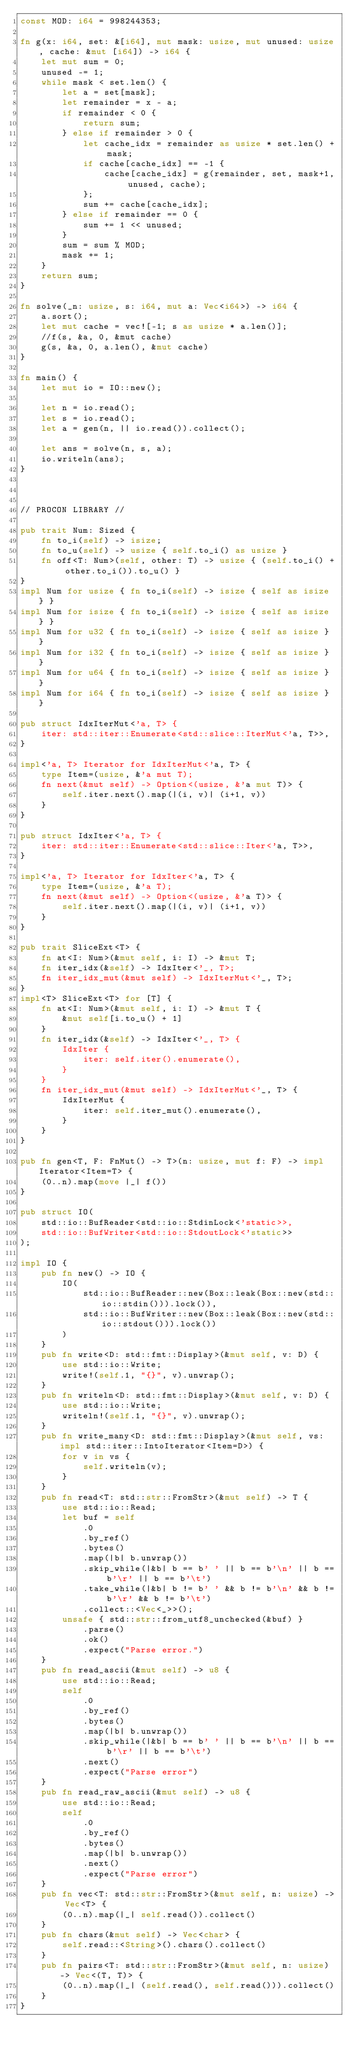<code> <loc_0><loc_0><loc_500><loc_500><_Rust_>const MOD: i64 = 998244353;

fn g(x: i64, set: &[i64], mut mask: usize, mut unused: usize, cache: &mut [i64]) -> i64 {
    let mut sum = 0;
    unused -= 1;
    while mask < set.len() {
        let a = set[mask];
        let remainder = x - a;
        if remainder < 0 {
            return sum;
        } else if remainder > 0 {
            let cache_idx = remainder as usize * set.len() + mask;
            if cache[cache_idx] == -1 {
                cache[cache_idx] = g(remainder, set, mask+1, unused, cache);
            };
            sum += cache[cache_idx];
        } else if remainder == 0 {
            sum += 1 << unused;
        }
        sum = sum % MOD;
        mask += 1;
    }
    return sum;
}

fn solve(_n: usize, s: i64, mut a: Vec<i64>) -> i64 {
    a.sort();
    let mut cache = vec![-1; s as usize * a.len()];
    //f(s, &a, 0, &mut cache)
    g(s, &a, 0, a.len(), &mut cache)
}

fn main() {
    let mut io = IO::new();

    let n = io.read();
    let s = io.read();
    let a = gen(n, || io.read()).collect();

    let ans = solve(n, s, a);
    io.writeln(ans);
}



// PROCON LIBRARY //

pub trait Num: Sized {
    fn to_i(self) -> isize;
    fn to_u(self) -> usize { self.to_i() as usize }
    fn off<T: Num>(self, other: T) -> usize { (self.to_i() + other.to_i()).to_u() }
}
impl Num for usize { fn to_i(self) -> isize { self as isize } }
impl Num for isize { fn to_i(self) -> isize { self as isize } }
impl Num for u32 { fn to_i(self) -> isize { self as isize } }
impl Num for i32 { fn to_i(self) -> isize { self as isize } }
impl Num for u64 { fn to_i(self) -> isize { self as isize } }
impl Num for i64 { fn to_i(self) -> isize { self as isize } }

pub struct IdxIterMut<'a, T> {
    iter: std::iter::Enumerate<std::slice::IterMut<'a, T>>,
}

impl<'a, T> Iterator for IdxIterMut<'a, T> {
    type Item=(usize, &'a mut T);
    fn next(&mut self) -> Option<(usize, &'a mut T)> {
        self.iter.next().map(|(i, v)| (i+1, v))
    }
}

pub struct IdxIter<'a, T> {
    iter: std::iter::Enumerate<std::slice::Iter<'a, T>>,
}

impl<'a, T> Iterator for IdxIter<'a, T> {
    type Item=(usize, &'a T);
    fn next(&mut self) -> Option<(usize, &'a T)> {
        self.iter.next().map(|(i, v)| (i+1, v))
    }
}

pub trait SliceExt<T> {
    fn at<I: Num>(&mut self, i: I) -> &mut T;
    fn iter_idx(&self) -> IdxIter<'_, T>;
    fn iter_idx_mut(&mut self) -> IdxIterMut<'_, T>;
}
impl<T> SliceExt<T> for [T] {
    fn at<I: Num>(&mut self, i: I) -> &mut T {
        &mut self[i.to_u() + 1]
    }
    fn iter_idx(&self) -> IdxIter<'_, T> {
        IdxIter {
            iter: self.iter().enumerate(),
        }
    }
    fn iter_idx_mut(&mut self) -> IdxIterMut<'_, T> {
        IdxIterMut {
            iter: self.iter_mut().enumerate(),
        }
    }
}

pub fn gen<T, F: FnMut() -> T>(n: usize, mut f: F) -> impl Iterator<Item=T> {
    (0..n).map(move |_| f())
}

pub struct IO(
    std::io::BufReader<std::io::StdinLock<'static>>,
    std::io::BufWriter<std::io::StdoutLock<'static>>
);

impl IO {
    pub fn new() -> IO {
        IO(
            std::io::BufReader::new(Box::leak(Box::new(std::io::stdin())).lock()),
            std::io::BufWriter::new(Box::leak(Box::new(std::io::stdout())).lock())
        )
    }
    pub fn write<D: std::fmt::Display>(&mut self, v: D) {
        use std::io::Write;
        write!(self.1, "{}", v).unwrap();
    }
    pub fn writeln<D: std::fmt::Display>(&mut self, v: D) {
        use std::io::Write;
        writeln!(self.1, "{}", v).unwrap();
    }
    pub fn write_many<D: std::fmt::Display>(&mut self, vs: impl std::iter::IntoIterator<Item=D>) {
        for v in vs {
            self.writeln(v);
        }
    }
    pub fn read<T: std::str::FromStr>(&mut self) -> T {
        use std::io::Read;
        let buf = self
            .0
            .by_ref()
            .bytes()
            .map(|b| b.unwrap())
            .skip_while(|&b| b == b' ' || b == b'\n' || b == b'\r' || b == b'\t')
            .take_while(|&b| b != b' ' && b != b'\n' && b != b'\r' && b != b'\t')
            .collect::<Vec<_>>();
        unsafe { std::str::from_utf8_unchecked(&buf) }
            .parse()
            .ok()
            .expect("Parse error.")
    }
    pub fn read_ascii(&mut self) -> u8 {
        use std::io::Read;
        self
            .0
            .by_ref()
            .bytes()
            .map(|b| b.unwrap())
            .skip_while(|&b| b == b' ' || b == b'\n' || b == b'\r' || b == b'\t')
            .next()
            .expect("Parse error")
    }
    pub fn read_raw_ascii(&mut self) -> u8 {
        use std::io::Read;
        self
            .0
            .by_ref()
            .bytes()
            .map(|b| b.unwrap())
            .next()
            .expect("Parse error")
    }
    pub fn vec<T: std::str::FromStr>(&mut self, n: usize) -> Vec<T> {
        (0..n).map(|_| self.read()).collect()
    }
    pub fn chars(&mut self) -> Vec<char> {
        self.read::<String>().chars().collect()
    }
    pub fn pairs<T: std::str::FromStr>(&mut self, n: usize) -> Vec<(T, T)> {
        (0..n).map(|_| (self.read(), self.read())).collect()
    }
}
</code> 